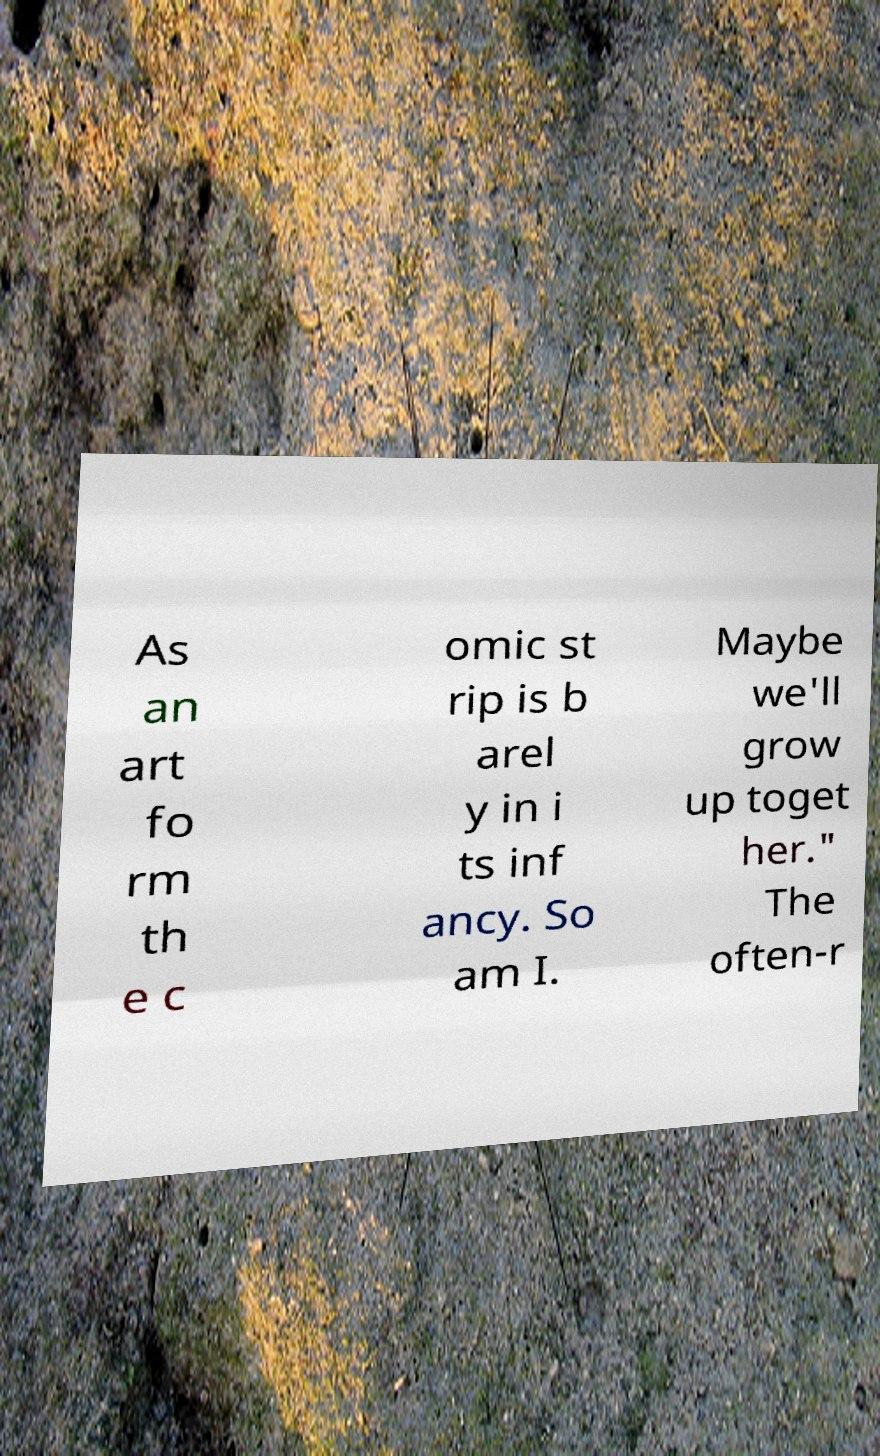Can you read and provide the text displayed in the image?This photo seems to have some interesting text. Can you extract and type it out for me? As an art fo rm th e c omic st rip is b arel y in i ts inf ancy. So am I. Maybe we'll grow up toget her." The often-r 